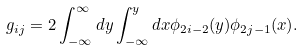<formula> <loc_0><loc_0><loc_500><loc_500>g _ { i j } = 2 \int _ { - \infty } ^ { \infty } d y \int _ { - \infty } ^ { y } d x \phi _ { 2 i - 2 } ( y ) \phi _ { 2 j - 1 } ( x ) .</formula> 